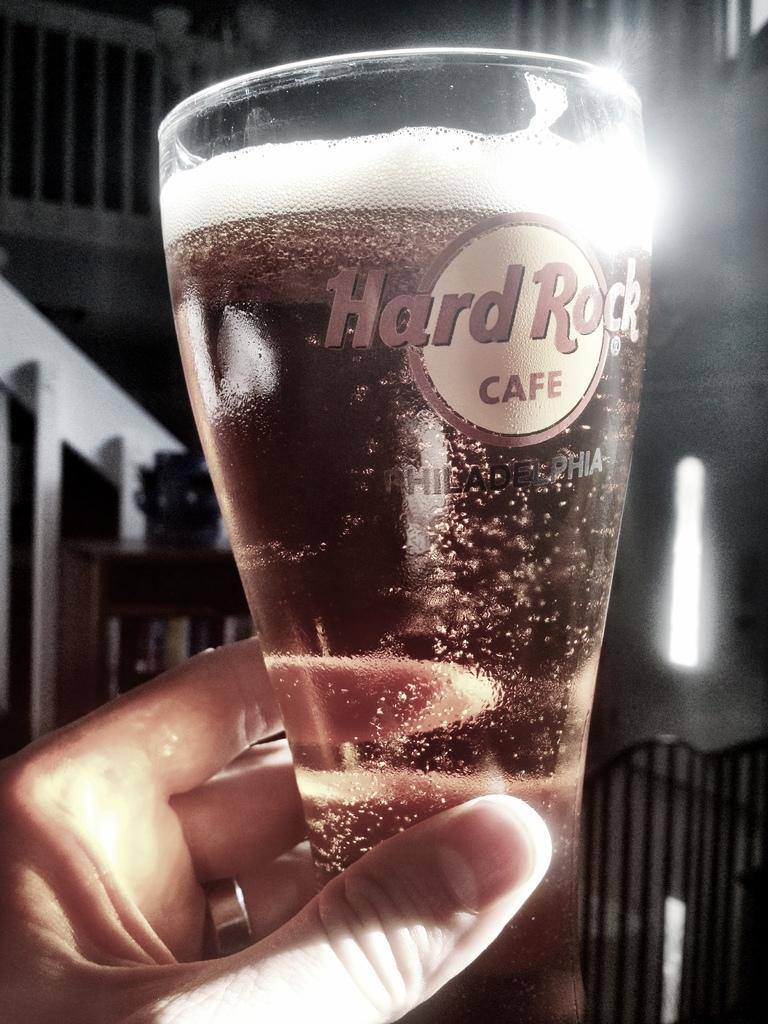Provide a one-sentence caption for the provided image. A hand with nice fingernails holds a glass of something from the hard rock cafe. 